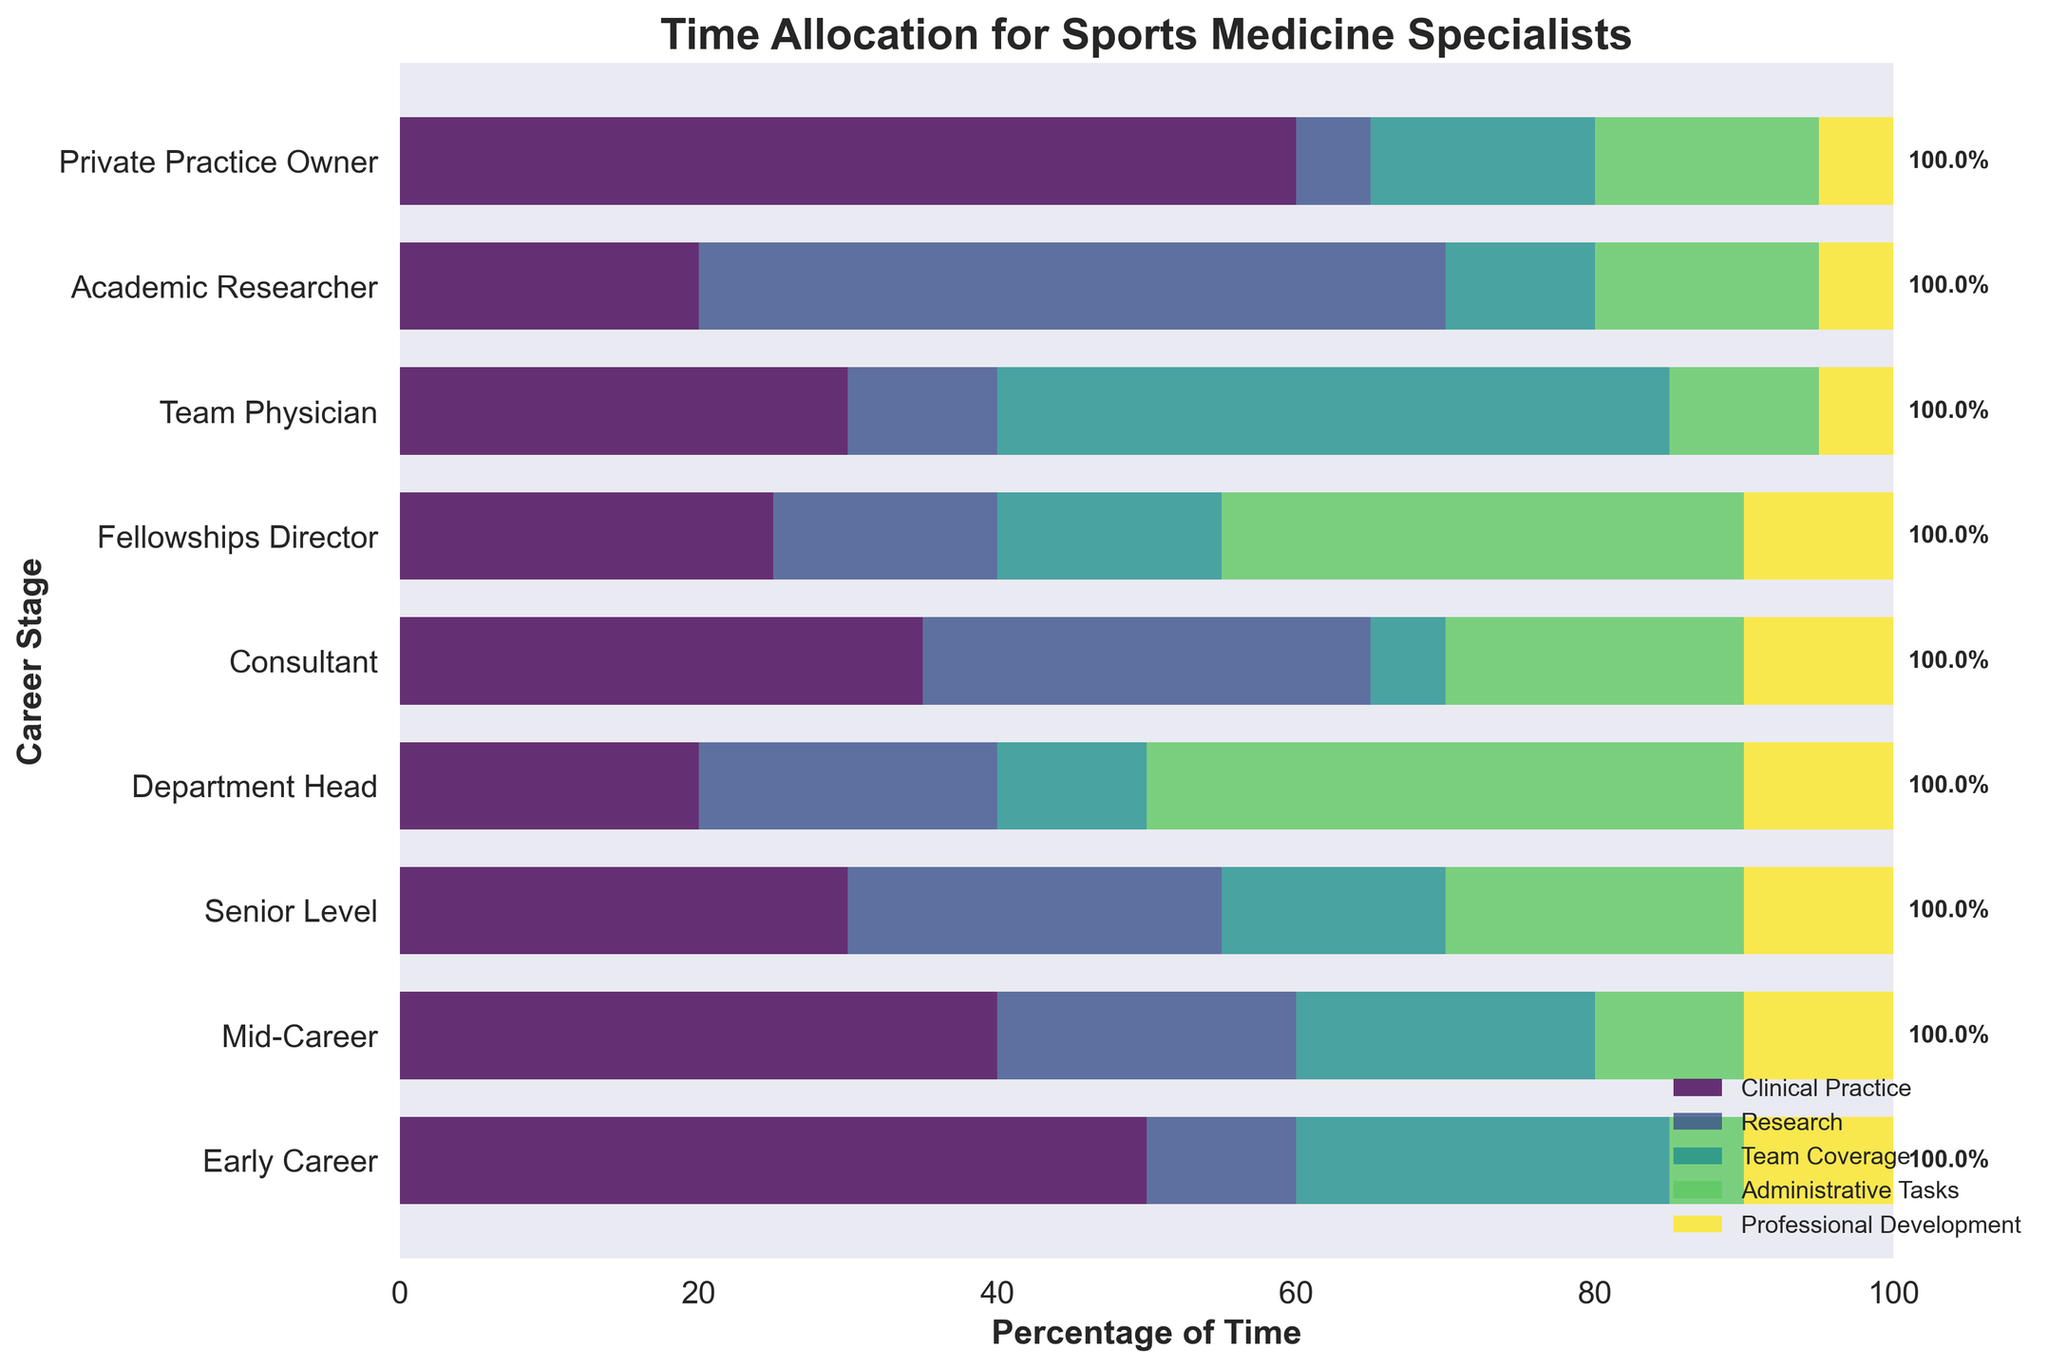What is the title of the figure? The title of the figure is usually found at the top, prominently displayed. It should be in bold and larger font size compared to other text elements.
Answer: Time Allocation for Sports Medicine Specialists Which career stage spends the most percentage of time on Clinical Practice? The figure shows different color bands representing each activity, with the length of each band corresponding to the percentage of time. For Clinical Practice, the longest band is for "Private Practice Owner."
Answer: Private Practice Owner How many career stages allocate exactly 10% of their time to Professional Development? The Professional Development activity is represented by a specific color. Counting all bars that end exactly at 10% in the professional development color will give the answer.
Answer: Nine What is the combined percentage of time spent on Research and Team Coverage for Mid-Career specialists? Locate the Mid-Career row, then sum the percentages for Research and Team Coverage (20%+20%).
Answer: 40% How does the percentage of time spent on Administrative Tasks differ between a Consultant and a Team Physician? Locate the bars for Administrative Tasks for both Consultant and Team Physician. The Consultant spends 20% while the Team Physician spends 10%. The difference is 20% - 10%.
Answer: 10% Which career stage has the highest percentage of time allocated to Research? Identify the longest bar corresponding to Research across all career stages. The career stage with the longest bar for Research is "Academic Researcher."
Answer: Academic Researcher What is the ratio of time spent on Clinical Practice to Administrative Tasks for a Department Head? For a Department Head, Clinical Practice is 20% and Administrative Tasks are 40%. The ratio is 20:40 which simplifies to 1:2.
Answer: 1:2 What is the total percentage of time allocated to Team Coverage by both Early Career and Team Physician specialists? Sum the percentages for Team Coverage for Early Career (25%) and Team Physician (45%).
Answer: 70% Which career stages allocate more than 25% of their time to Administrative Tasks? Identify career stages where the Administrative Tasks bar exceeds the 25% mark. Both "Department Head" and "Fellowships Director" have bars extending beyond 25%.
Answer: Department Head, Fellowships Director How do the total percentages of time spent on Clinical Practice and Professional Development compare for a Consultant? For a Consultant, Clinical Practice is 35% and Professional Development is 10%. Summing these gives 35% + 10% = 45%. Compare the two totals numerically.
Answer: Clinical Practice is higher by 25% 